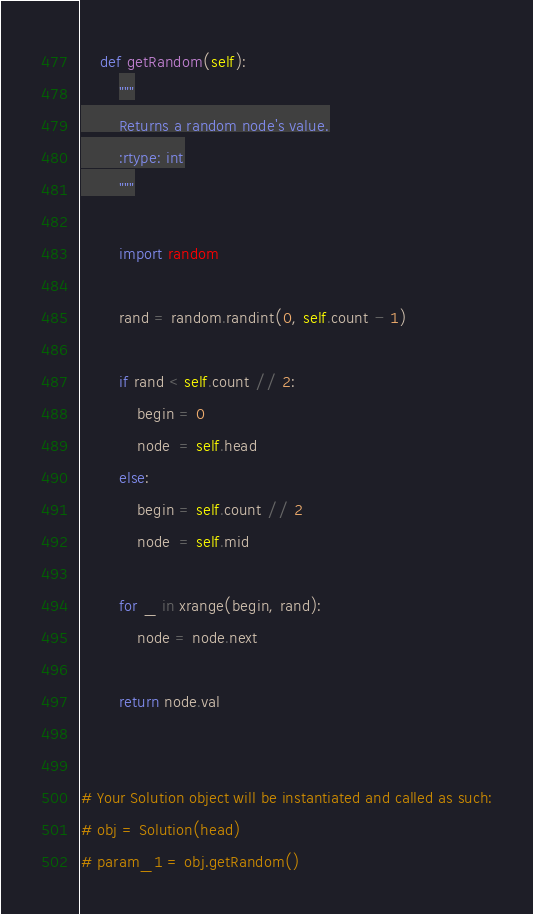Convert code to text. <code><loc_0><loc_0><loc_500><loc_500><_Python_>
    def getRandom(self):
        """
        Returns a random node's value.
        :rtype: int
        """
        
        import random
        
        rand = random.randint(0, self.count - 1)
                
        if rand < self.count // 2:
            begin = 0
            node  = self.head
        else:
            begin = self.count // 2
            node  = self.mid
            
        for _ in xrange(begin, rand):
            node = node.next
            
        return node.val
        
        
# Your Solution object will be instantiated and called as such:
# obj = Solution(head)
# param_1 = obj.getRandom()
</code> 